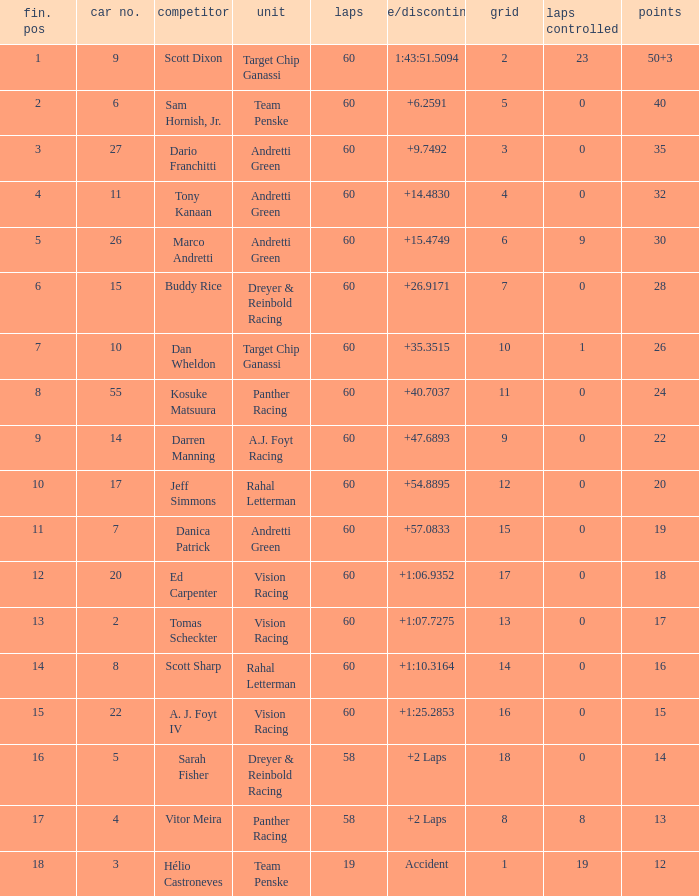Name the team for scott dixon Target Chip Ganassi. 